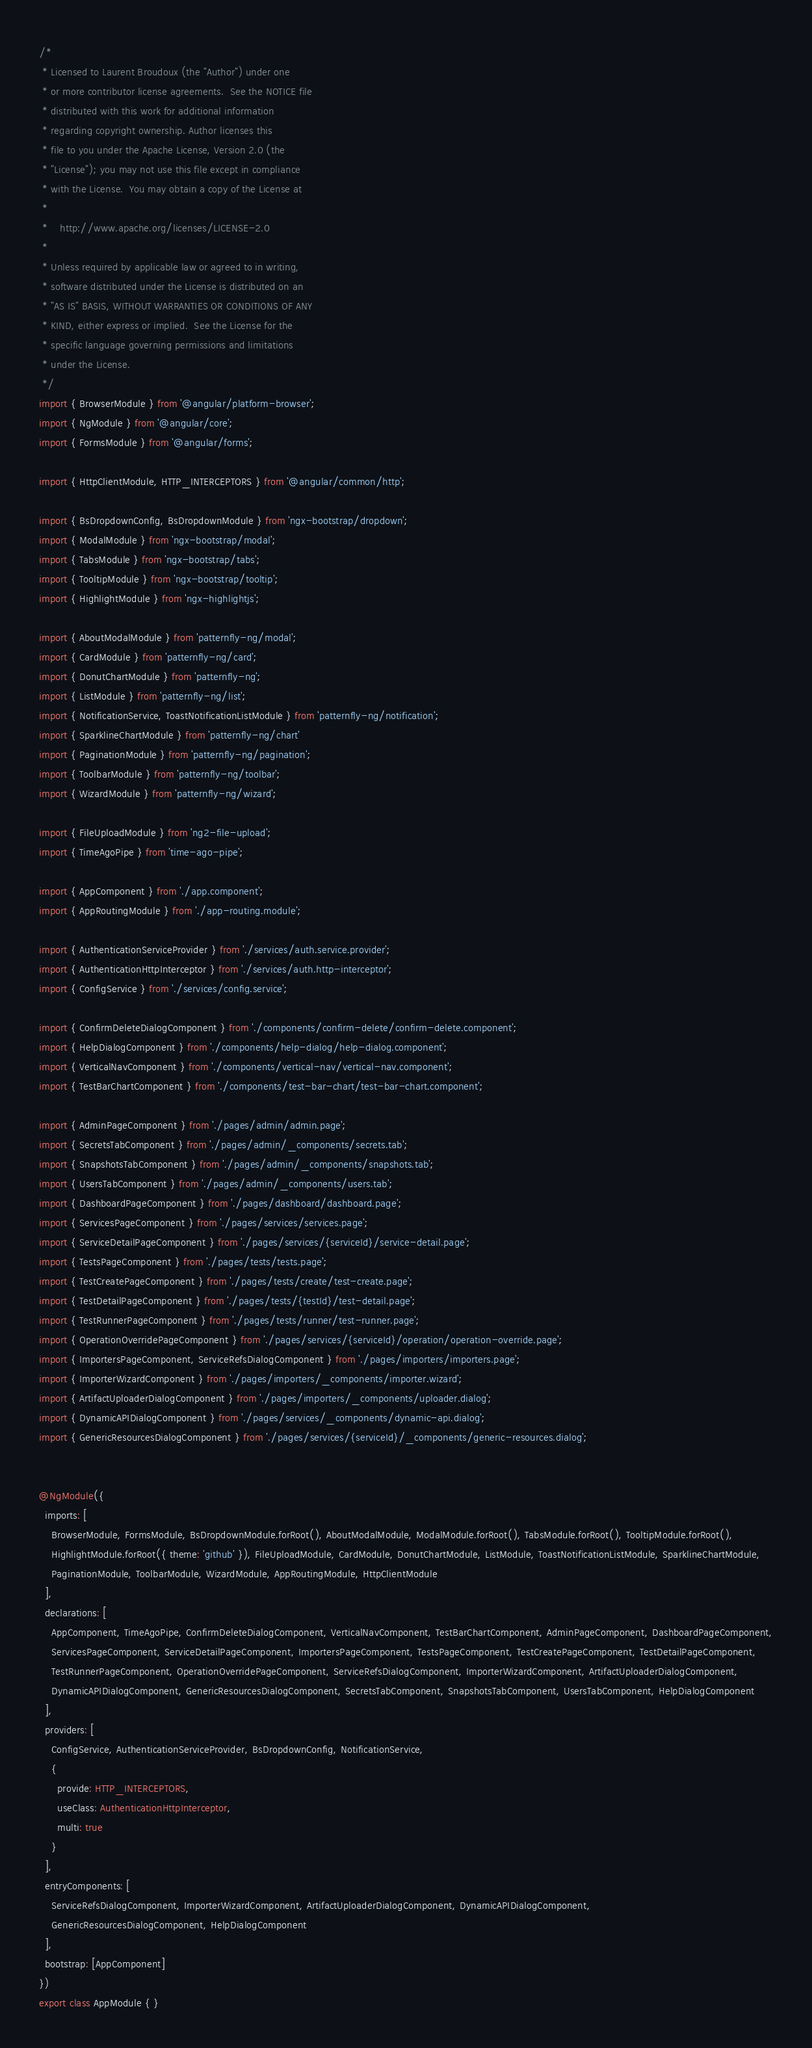<code> <loc_0><loc_0><loc_500><loc_500><_TypeScript_>/*
 * Licensed to Laurent Broudoux (the "Author") under one
 * or more contributor license agreements.  See the NOTICE file
 * distributed with this work for additional information
 * regarding copyright ownership. Author licenses this
 * file to you under the Apache License, Version 2.0 (the
 * "License"); you may not use this file except in compliance
 * with the License.  You may obtain a copy of the License at
 *
 *    http://www.apache.org/licenses/LICENSE-2.0
 *
 * Unless required by applicable law or agreed to in writing,
 * software distributed under the License is distributed on an
 * "AS IS" BASIS, WITHOUT WARRANTIES OR CONDITIONS OF ANY
 * KIND, either express or implied.  See the License for the
 * specific language governing permissions and limitations
 * under the License.
 */
import { BrowserModule } from '@angular/platform-browser';
import { NgModule } from '@angular/core';
import { FormsModule } from '@angular/forms';

import { HttpClientModule, HTTP_INTERCEPTORS } from '@angular/common/http';

import { BsDropdownConfig, BsDropdownModule } from 'ngx-bootstrap/dropdown';
import { ModalModule } from 'ngx-bootstrap/modal';
import { TabsModule } from 'ngx-bootstrap/tabs';
import { TooltipModule } from 'ngx-bootstrap/tooltip';
import { HighlightModule } from 'ngx-highlightjs';

import { AboutModalModule } from 'patternfly-ng/modal';
import { CardModule } from 'patternfly-ng/card';
import { DonutChartModule } from 'patternfly-ng';
import { ListModule } from 'patternfly-ng/list';
import { NotificationService, ToastNotificationListModule } from 'patternfly-ng/notification';
import { SparklineChartModule } from 'patternfly-ng/chart'
import { PaginationModule } from 'patternfly-ng/pagination';
import { ToolbarModule } from 'patternfly-ng/toolbar';
import { WizardModule } from 'patternfly-ng/wizard';

import { FileUploadModule } from 'ng2-file-upload';
import { TimeAgoPipe } from 'time-ago-pipe';

import { AppComponent } from './app.component';
import { AppRoutingModule } from './app-routing.module';

import { AuthenticationServiceProvider } from './services/auth.service.provider';
import { AuthenticationHttpInterceptor } from './services/auth.http-interceptor';
import { ConfigService } from './services/config.service';

import { ConfirmDeleteDialogComponent } from './components/confirm-delete/confirm-delete.component';
import { HelpDialogComponent } from './components/help-dialog/help-dialog.component';
import { VerticalNavComponent } from './components/vertical-nav/vertical-nav.component';
import { TestBarChartComponent } from './components/test-bar-chart/test-bar-chart.component';

import { AdminPageComponent } from './pages/admin/admin.page';
import { SecretsTabComponent } from './pages/admin/_components/secrets.tab';
import { SnapshotsTabComponent } from './pages/admin/_components/snapshots.tab';
import { UsersTabComponent } from './pages/admin/_components/users.tab';
import { DashboardPageComponent } from './pages/dashboard/dashboard.page';
import { ServicesPageComponent } from './pages/services/services.page';
import { ServiceDetailPageComponent } from './pages/services/{serviceId}/service-detail.page';
import { TestsPageComponent } from './pages/tests/tests.page';
import { TestCreatePageComponent } from './pages/tests/create/test-create.page';
import { TestDetailPageComponent } from './pages/tests/{testId}/test-detail.page';
import { TestRunnerPageComponent } from './pages/tests/runner/test-runner.page';
import { OperationOverridePageComponent } from './pages/services/{serviceId}/operation/operation-override.page';
import { ImportersPageComponent, ServiceRefsDialogComponent } from './pages/importers/importers.page';
import { ImporterWizardComponent } from './pages/importers/_components/importer.wizard';
import { ArtifactUploaderDialogComponent } from './pages/importers/_components/uploader.dialog';
import { DynamicAPIDialogComponent } from './pages/services/_components/dynamic-api.dialog';
import { GenericResourcesDialogComponent } from './pages/services/{serviceId}/_components/generic-resources.dialog';


@NgModule({
  imports: [
    BrowserModule, FormsModule, BsDropdownModule.forRoot(), AboutModalModule, ModalModule.forRoot(), TabsModule.forRoot(), TooltipModule.forRoot(), 
    HighlightModule.forRoot({ theme: 'github' }), FileUploadModule, CardModule, DonutChartModule, ListModule, ToastNotificationListModule, SparklineChartModule,
    PaginationModule, ToolbarModule, WizardModule, AppRoutingModule, HttpClientModule
  ],
  declarations: [
    AppComponent, TimeAgoPipe, ConfirmDeleteDialogComponent, VerticalNavComponent, TestBarChartComponent, AdminPageComponent, DashboardPageComponent,
    ServicesPageComponent, ServiceDetailPageComponent, ImportersPageComponent, TestsPageComponent, TestCreatePageComponent, TestDetailPageComponent,
    TestRunnerPageComponent, OperationOverridePageComponent, ServiceRefsDialogComponent, ImporterWizardComponent, ArtifactUploaderDialogComponent,
    DynamicAPIDialogComponent, GenericResourcesDialogComponent, SecretsTabComponent, SnapshotsTabComponent, UsersTabComponent, HelpDialogComponent
  ],
  providers: [
    ConfigService, AuthenticationServiceProvider, BsDropdownConfig, NotificationService,
    {
      provide: HTTP_INTERCEPTORS,
      useClass: AuthenticationHttpInterceptor,
      multi: true
    }
  ],
  entryComponents: [
    ServiceRefsDialogComponent, ImporterWizardComponent, ArtifactUploaderDialogComponent, DynamicAPIDialogComponent, 
    GenericResourcesDialogComponent, HelpDialogComponent
  ], 
  bootstrap: [AppComponent]
})
export class AppModule { }
</code> 